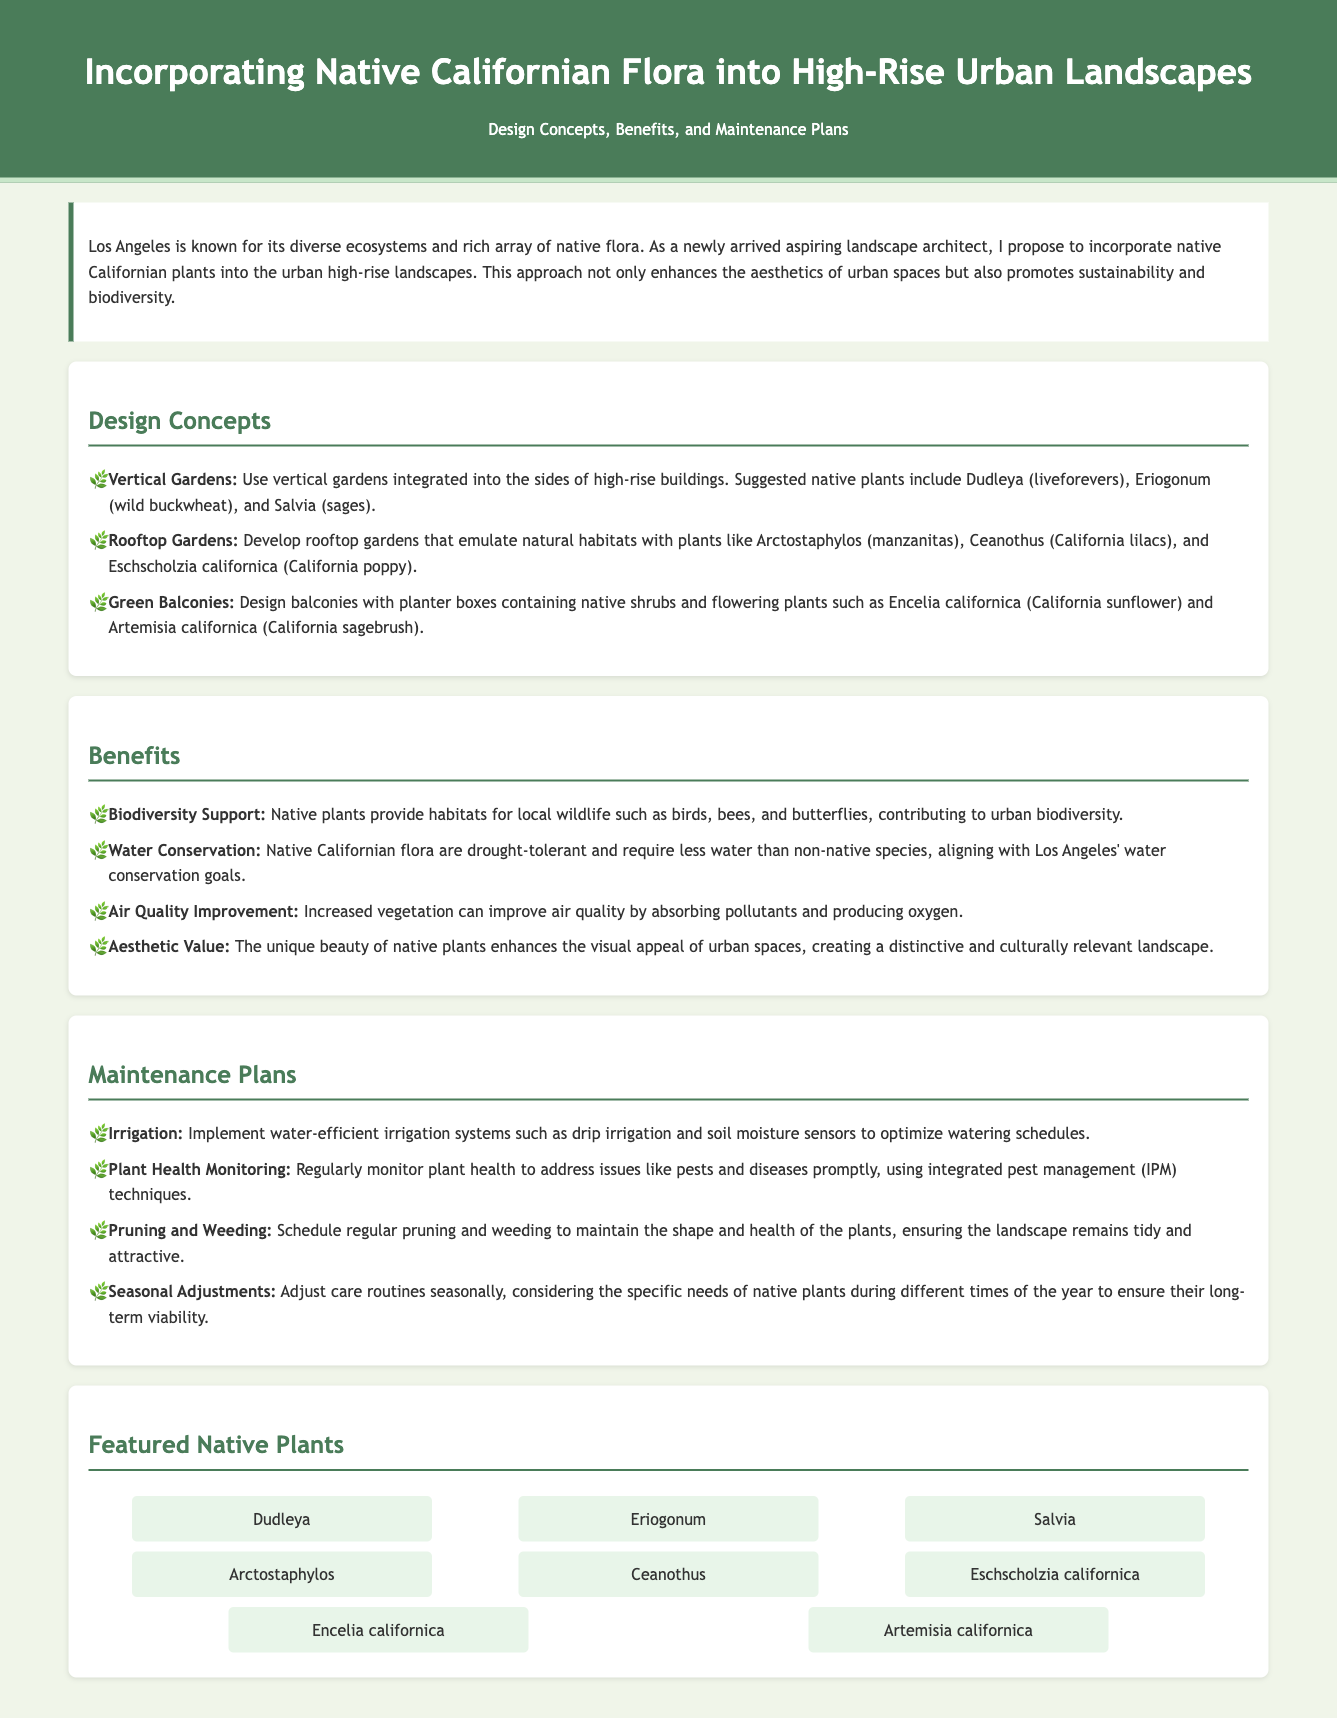what is the title of the proposal? The title of the proposal is prominently displayed at the top of the document.
Answer: Incorporating Native Californian Flora into High-Rise Urban Landscapes what are the three main design concepts presented? The design concepts are listed under the "Design Concepts" section.
Answer: Vertical Gardens, Rooftop Gardens, Green Balconies which plant is mentioned as a native California flower? The phrase used in the document identifies native plants including flowers specifically mentioned.
Answer: California poppy what is one benefit of incorporating native plants in urban landscapes? The benefits section outlines various positive aspects, including environmental contributions.
Answer: Water Conservation what type of irrigation system is recommended for maintenance? The maintenance plans outline strategies for plant care including irrigation systems.
Answer: Drip irrigation name one native shrub suggested for balconies. The design concepts include specific plants that can be used in balcony gardens.
Answer: California sunflower how many featured native plants are listed in the document? The number of plants can be determined from the "Featured Native Plants" section.
Answer: Eight what maintenance strategy involves adjusting methods based on the season? The maintenance plans specify various care strategies, including this seasonal adjustment.
Answer: Seasonal Adjustments 